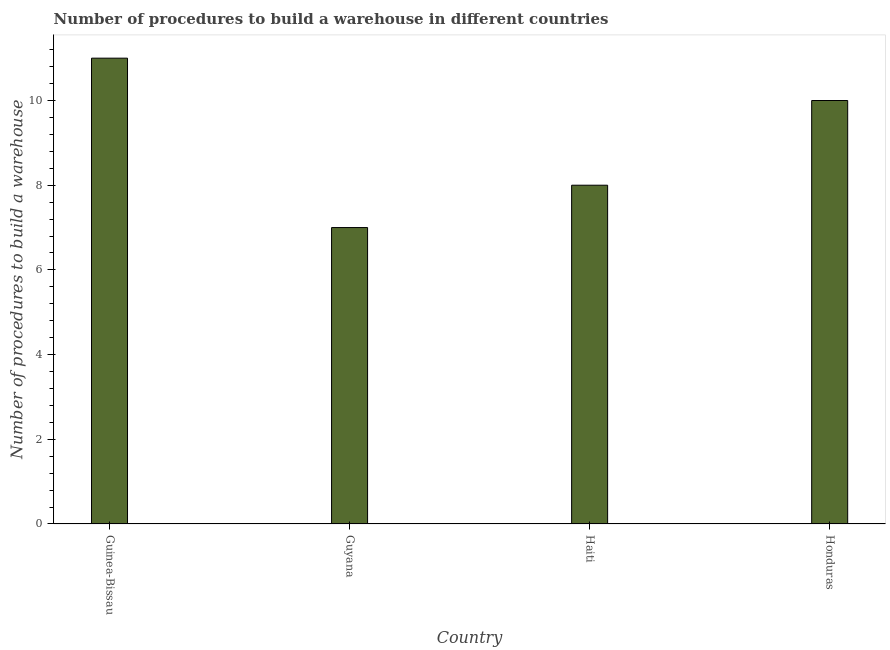Does the graph contain any zero values?
Provide a succinct answer. No. Does the graph contain grids?
Your response must be concise. No. What is the title of the graph?
Your answer should be very brief. Number of procedures to build a warehouse in different countries. What is the label or title of the Y-axis?
Your answer should be compact. Number of procedures to build a warehouse. In which country was the number of procedures to build a warehouse maximum?
Offer a very short reply. Guinea-Bissau. In which country was the number of procedures to build a warehouse minimum?
Your answer should be very brief. Guyana. What is the average number of procedures to build a warehouse per country?
Ensure brevity in your answer.  9. What is the median number of procedures to build a warehouse?
Keep it short and to the point. 9. In how many countries, is the number of procedures to build a warehouse greater than 3.6 ?
Your response must be concise. 4. Is the difference between the number of procedures to build a warehouse in Guinea-Bissau and Haiti greater than the difference between any two countries?
Ensure brevity in your answer.  No. In how many countries, is the number of procedures to build a warehouse greater than the average number of procedures to build a warehouse taken over all countries?
Offer a terse response. 2. How many bars are there?
Your answer should be very brief. 4. Are all the bars in the graph horizontal?
Offer a very short reply. No. How many countries are there in the graph?
Ensure brevity in your answer.  4. What is the difference between two consecutive major ticks on the Y-axis?
Provide a succinct answer. 2. What is the Number of procedures to build a warehouse in Guyana?
Offer a very short reply. 7. What is the Number of procedures to build a warehouse in Haiti?
Offer a very short reply. 8. What is the Number of procedures to build a warehouse in Honduras?
Give a very brief answer. 10. What is the difference between the Number of procedures to build a warehouse in Guinea-Bissau and Honduras?
Give a very brief answer. 1. What is the ratio of the Number of procedures to build a warehouse in Guinea-Bissau to that in Guyana?
Make the answer very short. 1.57. What is the ratio of the Number of procedures to build a warehouse in Guinea-Bissau to that in Haiti?
Give a very brief answer. 1.38. 